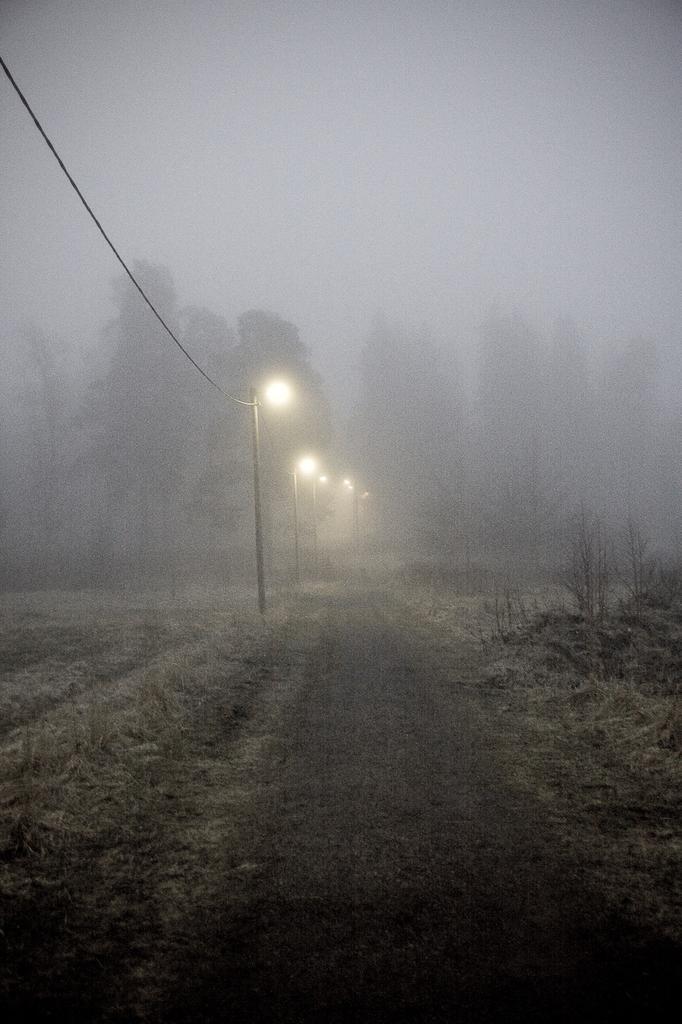Describe this image in one or two sentences. In the center of the image we can see electric light poles, wire, trees. At the bottom of the image we can see road, dry grass and some plants. At the top of the image we can see the sky. 